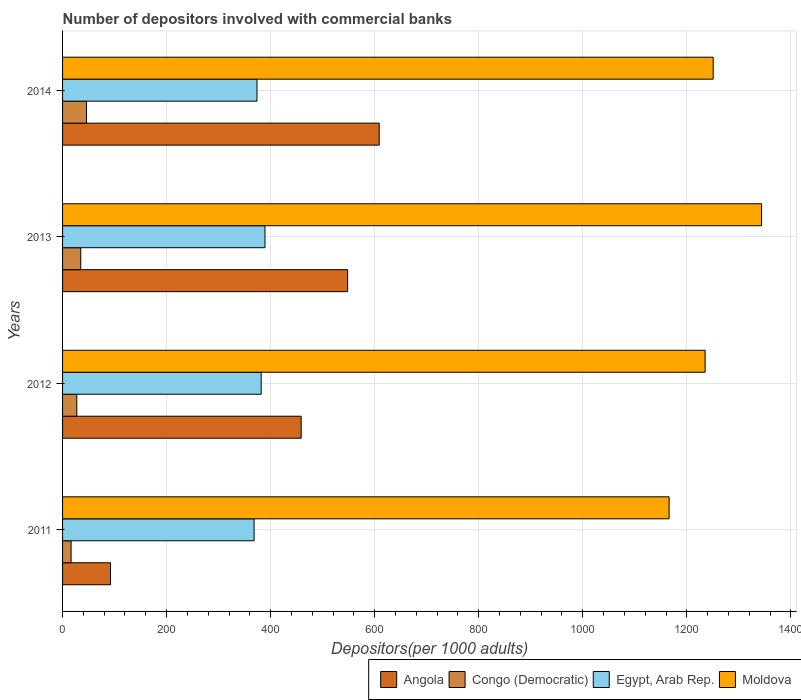How many different coloured bars are there?
Keep it short and to the point. 4. How many groups of bars are there?
Your answer should be very brief. 4. How many bars are there on the 2nd tick from the top?
Your answer should be very brief. 4. What is the label of the 3rd group of bars from the top?
Make the answer very short. 2012. What is the number of depositors involved with commercial banks in Moldova in 2014?
Make the answer very short. 1250.71. Across all years, what is the maximum number of depositors involved with commercial banks in Moldova?
Ensure brevity in your answer.  1343.66. Across all years, what is the minimum number of depositors involved with commercial banks in Egypt, Arab Rep.?
Offer a terse response. 368.19. In which year was the number of depositors involved with commercial banks in Angola maximum?
Make the answer very short. 2014. What is the total number of depositors involved with commercial banks in Egypt, Arab Rep. in the graph?
Offer a terse response. 1512.86. What is the difference between the number of depositors involved with commercial banks in Angola in 2011 and that in 2012?
Offer a terse response. -366.51. What is the difference between the number of depositors involved with commercial banks in Egypt, Arab Rep. in 2011 and the number of depositors involved with commercial banks in Angola in 2013?
Provide a short and direct response. -179.78. What is the average number of depositors involved with commercial banks in Moldova per year?
Provide a short and direct response. 1248.87. In the year 2014, what is the difference between the number of depositors involved with commercial banks in Egypt, Arab Rep. and number of depositors involved with commercial banks in Moldova?
Keep it short and to the point. -876.97. In how many years, is the number of depositors involved with commercial banks in Moldova greater than 1000 ?
Give a very brief answer. 4. What is the ratio of the number of depositors involved with commercial banks in Egypt, Arab Rep. in 2012 to that in 2014?
Your answer should be compact. 1.02. Is the number of depositors involved with commercial banks in Angola in 2011 less than that in 2013?
Offer a terse response. Yes. What is the difference between the highest and the second highest number of depositors involved with commercial banks in Moldova?
Keep it short and to the point. 92.95. What is the difference between the highest and the lowest number of depositors involved with commercial banks in Moldova?
Your answer should be compact. 177.73. In how many years, is the number of depositors involved with commercial banks in Congo (Democratic) greater than the average number of depositors involved with commercial banks in Congo (Democratic) taken over all years?
Keep it short and to the point. 2. Is the sum of the number of depositors involved with commercial banks in Angola in 2012 and 2014 greater than the maximum number of depositors involved with commercial banks in Egypt, Arab Rep. across all years?
Offer a terse response. Yes. What does the 2nd bar from the top in 2012 represents?
Provide a short and direct response. Egypt, Arab Rep. What does the 1st bar from the bottom in 2013 represents?
Offer a terse response. Angola. How many bars are there?
Make the answer very short. 16. How many years are there in the graph?
Your response must be concise. 4. Does the graph contain grids?
Make the answer very short. Yes. How many legend labels are there?
Provide a succinct answer. 4. What is the title of the graph?
Ensure brevity in your answer.  Number of depositors involved with commercial banks. Does "Turkey" appear as one of the legend labels in the graph?
Offer a terse response. No. What is the label or title of the X-axis?
Keep it short and to the point. Depositors(per 1000 adults). What is the Depositors(per 1000 adults) in Angola in 2011?
Offer a very short reply. 92.17. What is the Depositors(per 1000 adults) in Congo (Democratic) in 2011?
Provide a succinct answer. 16.41. What is the Depositors(per 1000 adults) of Egypt, Arab Rep. in 2011?
Offer a terse response. 368.19. What is the Depositors(per 1000 adults) of Moldova in 2011?
Provide a succinct answer. 1165.93. What is the Depositors(per 1000 adults) in Angola in 2012?
Give a very brief answer. 458.68. What is the Depositors(per 1000 adults) in Congo (Democratic) in 2012?
Your answer should be very brief. 27.36. What is the Depositors(per 1000 adults) in Egypt, Arab Rep. in 2012?
Your response must be concise. 381.83. What is the Depositors(per 1000 adults) of Moldova in 2012?
Your answer should be compact. 1235.18. What is the Depositors(per 1000 adults) in Angola in 2013?
Your response must be concise. 547.97. What is the Depositors(per 1000 adults) in Congo (Democratic) in 2013?
Offer a very short reply. 34.95. What is the Depositors(per 1000 adults) in Egypt, Arab Rep. in 2013?
Ensure brevity in your answer.  389.11. What is the Depositors(per 1000 adults) of Moldova in 2013?
Offer a very short reply. 1343.66. What is the Depositors(per 1000 adults) of Angola in 2014?
Give a very brief answer. 608.67. What is the Depositors(per 1000 adults) of Congo (Democratic) in 2014?
Your answer should be very brief. 46.03. What is the Depositors(per 1000 adults) of Egypt, Arab Rep. in 2014?
Offer a very short reply. 373.74. What is the Depositors(per 1000 adults) of Moldova in 2014?
Your response must be concise. 1250.71. Across all years, what is the maximum Depositors(per 1000 adults) in Angola?
Your answer should be compact. 608.67. Across all years, what is the maximum Depositors(per 1000 adults) of Congo (Democratic)?
Your response must be concise. 46.03. Across all years, what is the maximum Depositors(per 1000 adults) in Egypt, Arab Rep.?
Give a very brief answer. 389.11. Across all years, what is the maximum Depositors(per 1000 adults) in Moldova?
Give a very brief answer. 1343.66. Across all years, what is the minimum Depositors(per 1000 adults) of Angola?
Your answer should be compact. 92.17. Across all years, what is the minimum Depositors(per 1000 adults) in Congo (Democratic)?
Ensure brevity in your answer.  16.41. Across all years, what is the minimum Depositors(per 1000 adults) in Egypt, Arab Rep.?
Keep it short and to the point. 368.19. Across all years, what is the minimum Depositors(per 1000 adults) in Moldova?
Provide a short and direct response. 1165.93. What is the total Depositors(per 1000 adults) in Angola in the graph?
Offer a terse response. 1707.5. What is the total Depositors(per 1000 adults) in Congo (Democratic) in the graph?
Keep it short and to the point. 124.75. What is the total Depositors(per 1000 adults) in Egypt, Arab Rep. in the graph?
Offer a terse response. 1512.86. What is the total Depositors(per 1000 adults) in Moldova in the graph?
Provide a short and direct response. 4995.48. What is the difference between the Depositors(per 1000 adults) of Angola in 2011 and that in 2012?
Offer a terse response. -366.51. What is the difference between the Depositors(per 1000 adults) in Congo (Democratic) in 2011 and that in 2012?
Your answer should be very brief. -10.96. What is the difference between the Depositors(per 1000 adults) of Egypt, Arab Rep. in 2011 and that in 2012?
Your response must be concise. -13.63. What is the difference between the Depositors(per 1000 adults) of Moldova in 2011 and that in 2012?
Provide a succinct answer. -69.25. What is the difference between the Depositors(per 1000 adults) in Angola in 2011 and that in 2013?
Your answer should be very brief. -455.8. What is the difference between the Depositors(per 1000 adults) of Congo (Democratic) in 2011 and that in 2013?
Make the answer very short. -18.55. What is the difference between the Depositors(per 1000 adults) of Egypt, Arab Rep. in 2011 and that in 2013?
Offer a terse response. -20.91. What is the difference between the Depositors(per 1000 adults) in Moldova in 2011 and that in 2013?
Give a very brief answer. -177.73. What is the difference between the Depositors(per 1000 adults) of Angola in 2011 and that in 2014?
Offer a very short reply. -516.49. What is the difference between the Depositors(per 1000 adults) of Congo (Democratic) in 2011 and that in 2014?
Offer a terse response. -29.62. What is the difference between the Depositors(per 1000 adults) in Egypt, Arab Rep. in 2011 and that in 2014?
Make the answer very short. -5.54. What is the difference between the Depositors(per 1000 adults) in Moldova in 2011 and that in 2014?
Your answer should be very brief. -84.78. What is the difference between the Depositors(per 1000 adults) of Angola in 2012 and that in 2013?
Keep it short and to the point. -89.29. What is the difference between the Depositors(per 1000 adults) in Congo (Democratic) in 2012 and that in 2013?
Offer a very short reply. -7.59. What is the difference between the Depositors(per 1000 adults) of Egypt, Arab Rep. in 2012 and that in 2013?
Provide a short and direct response. -7.28. What is the difference between the Depositors(per 1000 adults) in Moldova in 2012 and that in 2013?
Offer a very short reply. -108.47. What is the difference between the Depositors(per 1000 adults) of Angola in 2012 and that in 2014?
Offer a very short reply. -149.98. What is the difference between the Depositors(per 1000 adults) in Congo (Democratic) in 2012 and that in 2014?
Offer a terse response. -18.67. What is the difference between the Depositors(per 1000 adults) of Egypt, Arab Rep. in 2012 and that in 2014?
Give a very brief answer. 8.09. What is the difference between the Depositors(per 1000 adults) of Moldova in 2012 and that in 2014?
Keep it short and to the point. -15.53. What is the difference between the Depositors(per 1000 adults) of Angola in 2013 and that in 2014?
Your answer should be very brief. -60.69. What is the difference between the Depositors(per 1000 adults) in Congo (Democratic) in 2013 and that in 2014?
Provide a short and direct response. -11.08. What is the difference between the Depositors(per 1000 adults) of Egypt, Arab Rep. in 2013 and that in 2014?
Your answer should be compact. 15.37. What is the difference between the Depositors(per 1000 adults) of Moldova in 2013 and that in 2014?
Offer a terse response. 92.95. What is the difference between the Depositors(per 1000 adults) of Angola in 2011 and the Depositors(per 1000 adults) of Congo (Democratic) in 2012?
Your answer should be very brief. 64.81. What is the difference between the Depositors(per 1000 adults) in Angola in 2011 and the Depositors(per 1000 adults) in Egypt, Arab Rep. in 2012?
Provide a succinct answer. -289.65. What is the difference between the Depositors(per 1000 adults) in Angola in 2011 and the Depositors(per 1000 adults) in Moldova in 2012?
Your answer should be compact. -1143.01. What is the difference between the Depositors(per 1000 adults) of Congo (Democratic) in 2011 and the Depositors(per 1000 adults) of Egypt, Arab Rep. in 2012?
Your response must be concise. -365.42. What is the difference between the Depositors(per 1000 adults) of Congo (Democratic) in 2011 and the Depositors(per 1000 adults) of Moldova in 2012?
Give a very brief answer. -1218.78. What is the difference between the Depositors(per 1000 adults) of Egypt, Arab Rep. in 2011 and the Depositors(per 1000 adults) of Moldova in 2012?
Your response must be concise. -866.99. What is the difference between the Depositors(per 1000 adults) in Angola in 2011 and the Depositors(per 1000 adults) in Congo (Democratic) in 2013?
Offer a very short reply. 57.22. What is the difference between the Depositors(per 1000 adults) in Angola in 2011 and the Depositors(per 1000 adults) in Egypt, Arab Rep. in 2013?
Offer a terse response. -296.93. What is the difference between the Depositors(per 1000 adults) of Angola in 2011 and the Depositors(per 1000 adults) of Moldova in 2013?
Make the answer very short. -1251.48. What is the difference between the Depositors(per 1000 adults) of Congo (Democratic) in 2011 and the Depositors(per 1000 adults) of Egypt, Arab Rep. in 2013?
Offer a terse response. -372.7. What is the difference between the Depositors(per 1000 adults) of Congo (Democratic) in 2011 and the Depositors(per 1000 adults) of Moldova in 2013?
Make the answer very short. -1327.25. What is the difference between the Depositors(per 1000 adults) of Egypt, Arab Rep. in 2011 and the Depositors(per 1000 adults) of Moldova in 2013?
Your answer should be compact. -975.46. What is the difference between the Depositors(per 1000 adults) of Angola in 2011 and the Depositors(per 1000 adults) of Congo (Democratic) in 2014?
Provide a short and direct response. 46.15. What is the difference between the Depositors(per 1000 adults) in Angola in 2011 and the Depositors(per 1000 adults) in Egypt, Arab Rep. in 2014?
Provide a short and direct response. -281.56. What is the difference between the Depositors(per 1000 adults) in Angola in 2011 and the Depositors(per 1000 adults) in Moldova in 2014?
Your response must be concise. -1158.53. What is the difference between the Depositors(per 1000 adults) of Congo (Democratic) in 2011 and the Depositors(per 1000 adults) of Egypt, Arab Rep. in 2014?
Provide a succinct answer. -357.33. What is the difference between the Depositors(per 1000 adults) in Congo (Democratic) in 2011 and the Depositors(per 1000 adults) in Moldova in 2014?
Keep it short and to the point. -1234.3. What is the difference between the Depositors(per 1000 adults) in Egypt, Arab Rep. in 2011 and the Depositors(per 1000 adults) in Moldova in 2014?
Your answer should be very brief. -882.52. What is the difference between the Depositors(per 1000 adults) of Angola in 2012 and the Depositors(per 1000 adults) of Congo (Democratic) in 2013?
Your answer should be compact. 423.73. What is the difference between the Depositors(per 1000 adults) in Angola in 2012 and the Depositors(per 1000 adults) in Egypt, Arab Rep. in 2013?
Offer a very short reply. 69.58. What is the difference between the Depositors(per 1000 adults) in Angola in 2012 and the Depositors(per 1000 adults) in Moldova in 2013?
Offer a very short reply. -884.98. What is the difference between the Depositors(per 1000 adults) in Congo (Democratic) in 2012 and the Depositors(per 1000 adults) in Egypt, Arab Rep. in 2013?
Provide a succinct answer. -361.74. What is the difference between the Depositors(per 1000 adults) of Congo (Democratic) in 2012 and the Depositors(per 1000 adults) of Moldova in 2013?
Your answer should be very brief. -1316.3. What is the difference between the Depositors(per 1000 adults) of Egypt, Arab Rep. in 2012 and the Depositors(per 1000 adults) of Moldova in 2013?
Ensure brevity in your answer.  -961.83. What is the difference between the Depositors(per 1000 adults) in Angola in 2012 and the Depositors(per 1000 adults) in Congo (Democratic) in 2014?
Offer a very short reply. 412.66. What is the difference between the Depositors(per 1000 adults) of Angola in 2012 and the Depositors(per 1000 adults) of Egypt, Arab Rep. in 2014?
Your answer should be compact. 84.95. What is the difference between the Depositors(per 1000 adults) of Angola in 2012 and the Depositors(per 1000 adults) of Moldova in 2014?
Give a very brief answer. -792.03. What is the difference between the Depositors(per 1000 adults) of Congo (Democratic) in 2012 and the Depositors(per 1000 adults) of Egypt, Arab Rep. in 2014?
Make the answer very short. -346.37. What is the difference between the Depositors(per 1000 adults) in Congo (Democratic) in 2012 and the Depositors(per 1000 adults) in Moldova in 2014?
Ensure brevity in your answer.  -1223.35. What is the difference between the Depositors(per 1000 adults) in Egypt, Arab Rep. in 2012 and the Depositors(per 1000 adults) in Moldova in 2014?
Provide a short and direct response. -868.88. What is the difference between the Depositors(per 1000 adults) of Angola in 2013 and the Depositors(per 1000 adults) of Congo (Democratic) in 2014?
Make the answer very short. 501.94. What is the difference between the Depositors(per 1000 adults) in Angola in 2013 and the Depositors(per 1000 adults) in Egypt, Arab Rep. in 2014?
Your answer should be compact. 174.24. What is the difference between the Depositors(per 1000 adults) in Angola in 2013 and the Depositors(per 1000 adults) in Moldova in 2014?
Ensure brevity in your answer.  -702.74. What is the difference between the Depositors(per 1000 adults) in Congo (Democratic) in 2013 and the Depositors(per 1000 adults) in Egypt, Arab Rep. in 2014?
Give a very brief answer. -338.79. What is the difference between the Depositors(per 1000 adults) in Congo (Democratic) in 2013 and the Depositors(per 1000 adults) in Moldova in 2014?
Offer a terse response. -1215.76. What is the difference between the Depositors(per 1000 adults) of Egypt, Arab Rep. in 2013 and the Depositors(per 1000 adults) of Moldova in 2014?
Give a very brief answer. -861.6. What is the average Depositors(per 1000 adults) of Angola per year?
Give a very brief answer. 426.87. What is the average Depositors(per 1000 adults) of Congo (Democratic) per year?
Offer a very short reply. 31.19. What is the average Depositors(per 1000 adults) of Egypt, Arab Rep. per year?
Your response must be concise. 378.22. What is the average Depositors(per 1000 adults) in Moldova per year?
Provide a succinct answer. 1248.87. In the year 2011, what is the difference between the Depositors(per 1000 adults) of Angola and Depositors(per 1000 adults) of Congo (Democratic)?
Give a very brief answer. 75.77. In the year 2011, what is the difference between the Depositors(per 1000 adults) in Angola and Depositors(per 1000 adults) in Egypt, Arab Rep.?
Provide a succinct answer. -276.02. In the year 2011, what is the difference between the Depositors(per 1000 adults) of Angola and Depositors(per 1000 adults) of Moldova?
Ensure brevity in your answer.  -1073.76. In the year 2011, what is the difference between the Depositors(per 1000 adults) in Congo (Democratic) and Depositors(per 1000 adults) in Egypt, Arab Rep.?
Give a very brief answer. -351.79. In the year 2011, what is the difference between the Depositors(per 1000 adults) in Congo (Democratic) and Depositors(per 1000 adults) in Moldova?
Your response must be concise. -1149.52. In the year 2011, what is the difference between the Depositors(per 1000 adults) of Egypt, Arab Rep. and Depositors(per 1000 adults) of Moldova?
Provide a short and direct response. -797.74. In the year 2012, what is the difference between the Depositors(per 1000 adults) in Angola and Depositors(per 1000 adults) in Congo (Democratic)?
Offer a very short reply. 431.32. In the year 2012, what is the difference between the Depositors(per 1000 adults) in Angola and Depositors(per 1000 adults) in Egypt, Arab Rep.?
Ensure brevity in your answer.  76.86. In the year 2012, what is the difference between the Depositors(per 1000 adults) in Angola and Depositors(per 1000 adults) in Moldova?
Provide a short and direct response. -776.5. In the year 2012, what is the difference between the Depositors(per 1000 adults) in Congo (Democratic) and Depositors(per 1000 adults) in Egypt, Arab Rep.?
Provide a short and direct response. -354.46. In the year 2012, what is the difference between the Depositors(per 1000 adults) in Congo (Democratic) and Depositors(per 1000 adults) in Moldova?
Ensure brevity in your answer.  -1207.82. In the year 2012, what is the difference between the Depositors(per 1000 adults) of Egypt, Arab Rep. and Depositors(per 1000 adults) of Moldova?
Provide a short and direct response. -853.36. In the year 2013, what is the difference between the Depositors(per 1000 adults) of Angola and Depositors(per 1000 adults) of Congo (Democratic)?
Offer a terse response. 513.02. In the year 2013, what is the difference between the Depositors(per 1000 adults) in Angola and Depositors(per 1000 adults) in Egypt, Arab Rep.?
Provide a succinct answer. 158.87. In the year 2013, what is the difference between the Depositors(per 1000 adults) of Angola and Depositors(per 1000 adults) of Moldova?
Your response must be concise. -795.69. In the year 2013, what is the difference between the Depositors(per 1000 adults) in Congo (Democratic) and Depositors(per 1000 adults) in Egypt, Arab Rep.?
Offer a very short reply. -354.15. In the year 2013, what is the difference between the Depositors(per 1000 adults) of Congo (Democratic) and Depositors(per 1000 adults) of Moldova?
Provide a succinct answer. -1308.71. In the year 2013, what is the difference between the Depositors(per 1000 adults) in Egypt, Arab Rep. and Depositors(per 1000 adults) in Moldova?
Offer a very short reply. -954.55. In the year 2014, what is the difference between the Depositors(per 1000 adults) of Angola and Depositors(per 1000 adults) of Congo (Democratic)?
Give a very brief answer. 562.64. In the year 2014, what is the difference between the Depositors(per 1000 adults) in Angola and Depositors(per 1000 adults) in Egypt, Arab Rep.?
Your answer should be compact. 234.93. In the year 2014, what is the difference between the Depositors(per 1000 adults) in Angola and Depositors(per 1000 adults) in Moldova?
Offer a very short reply. -642.04. In the year 2014, what is the difference between the Depositors(per 1000 adults) in Congo (Democratic) and Depositors(per 1000 adults) in Egypt, Arab Rep.?
Make the answer very short. -327.71. In the year 2014, what is the difference between the Depositors(per 1000 adults) of Congo (Democratic) and Depositors(per 1000 adults) of Moldova?
Offer a terse response. -1204.68. In the year 2014, what is the difference between the Depositors(per 1000 adults) in Egypt, Arab Rep. and Depositors(per 1000 adults) in Moldova?
Make the answer very short. -876.97. What is the ratio of the Depositors(per 1000 adults) of Angola in 2011 to that in 2012?
Keep it short and to the point. 0.2. What is the ratio of the Depositors(per 1000 adults) of Congo (Democratic) in 2011 to that in 2012?
Offer a very short reply. 0.6. What is the ratio of the Depositors(per 1000 adults) of Egypt, Arab Rep. in 2011 to that in 2012?
Keep it short and to the point. 0.96. What is the ratio of the Depositors(per 1000 adults) of Moldova in 2011 to that in 2012?
Offer a terse response. 0.94. What is the ratio of the Depositors(per 1000 adults) of Angola in 2011 to that in 2013?
Provide a short and direct response. 0.17. What is the ratio of the Depositors(per 1000 adults) in Congo (Democratic) in 2011 to that in 2013?
Offer a very short reply. 0.47. What is the ratio of the Depositors(per 1000 adults) of Egypt, Arab Rep. in 2011 to that in 2013?
Your answer should be very brief. 0.95. What is the ratio of the Depositors(per 1000 adults) of Moldova in 2011 to that in 2013?
Give a very brief answer. 0.87. What is the ratio of the Depositors(per 1000 adults) in Angola in 2011 to that in 2014?
Your answer should be very brief. 0.15. What is the ratio of the Depositors(per 1000 adults) in Congo (Democratic) in 2011 to that in 2014?
Your answer should be very brief. 0.36. What is the ratio of the Depositors(per 1000 adults) in Egypt, Arab Rep. in 2011 to that in 2014?
Provide a short and direct response. 0.99. What is the ratio of the Depositors(per 1000 adults) in Moldova in 2011 to that in 2014?
Ensure brevity in your answer.  0.93. What is the ratio of the Depositors(per 1000 adults) in Angola in 2012 to that in 2013?
Offer a very short reply. 0.84. What is the ratio of the Depositors(per 1000 adults) in Congo (Democratic) in 2012 to that in 2013?
Provide a short and direct response. 0.78. What is the ratio of the Depositors(per 1000 adults) of Egypt, Arab Rep. in 2012 to that in 2013?
Your answer should be very brief. 0.98. What is the ratio of the Depositors(per 1000 adults) in Moldova in 2012 to that in 2013?
Your answer should be very brief. 0.92. What is the ratio of the Depositors(per 1000 adults) of Angola in 2012 to that in 2014?
Your response must be concise. 0.75. What is the ratio of the Depositors(per 1000 adults) of Congo (Democratic) in 2012 to that in 2014?
Your answer should be very brief. 0.59. What is the ratio of the Depositors(per 1000 adults) in Egypt, Arab Rep. in 2012 to that in 2014?
Keep it short and to the point. 1.02. What is the ratio of the Depositors(per 1000 adults) of Moldova in 2012 to that in 2014?
Your answer should be compact. 0.99. What is the ratio of the Depositors(per 1000 adults) of Angola in 2013 to that in 2014?
Offer a terse response. 0.9. What is the ratio of the Depositors(per 1000 adults) of Congo (Democratic) in 2013 to that in 2014?
Offer a terse response. 0.76. What is the ratio of the Depositors(per 1000 adults) of Egypt, Arab Rep. in 2013 to that in 2014?
Provide a succinct answer. 1.04. What is the ratio of the Depositors(per 1000 adults) in Moldova in 2013 to that in 2014?
Ensure brevity in your answer.  1.07. What is the difference between the highest and the second highest Depositors(per 1000 adults) in Angola?
Provide a succinct answer. 60.69. What is the difference between the highest and the second highest Depositors(per 1000 adults) of Congo (Democratic)?
Make the answer very short. 11.08. What is the difference between the highest and the second highest Depositors(per 1000 adults) in Egypt, Arab Rep.?
Make the answer very short. 7.28. What is the difference between the highest and the second highest Depositors(per 1000 adults) in Moldova?
Your answer should be very brief. 92.95. What is the difference between the highest and the lowest Depositors(per 1000 adults) in Angola?
Make the answer very short. 516.49. What is the difference between the highest and the lowest Depositors(per 1000 adults) of Congo (Democratic)?
Your response must be concise. 29.62. What is the difference between the highest and the lowest Depositors(per 1000 adults) of Egypt, Arab Rep.?
Offer a terse response. 20.91. What is the difference between the highest and the lowest Depositors(per 1000 adults) of Moldova?
Your response must be concise. 177.73. 